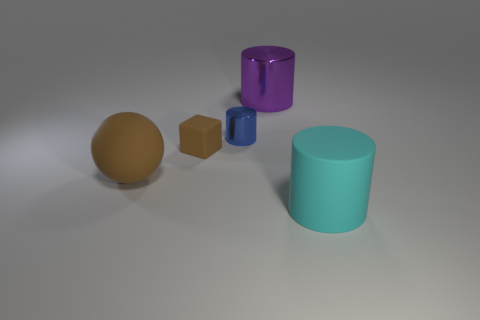Subtract all tiny cylinders. How many cylinders are left? 2 Add 3 brown objects. How many objects exist? 8 Subtract all cylinders. How many objects are left? 2 Add 2 small cylinders. How many small cylinders are left? 3 Add 5 blue rubber cylinders. How many blue rubber cylinders exist? 5 Subtract 0 green cylinders. How many objects are left? 5 Subtract all blue cylinders. Subtract all yellow blocks. How many cylinders are left? 2 Subtract all yellow cubes. Subtract all big shiny cylinders. How many objects are left? 4 